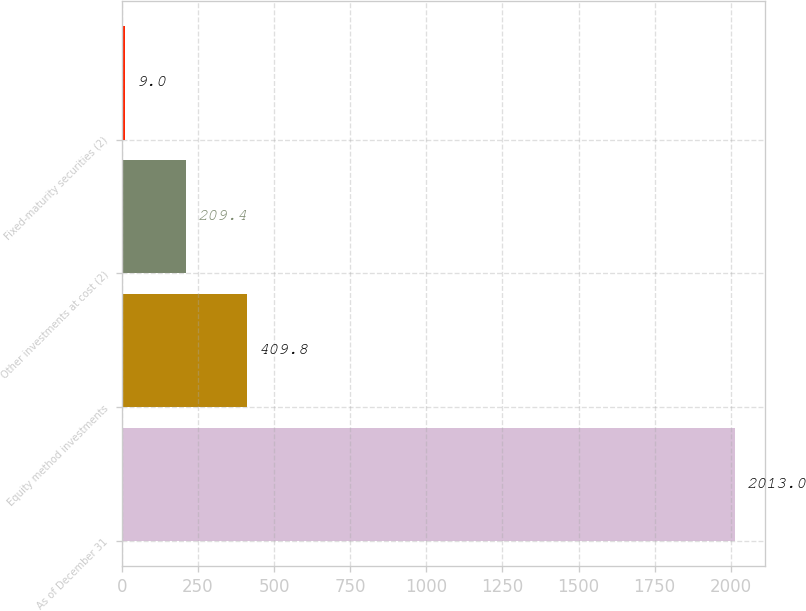Convert chart to OTSL. <chart><loc_0><loc_0><loc_500><loc_500><bar_chart><fcel>As of December 31<fcel>Equity method investments<fcel>Other investments at cost (2)<fcel>Fixed-maturity securities (2)<nl><fcel>2013<fcel>409.8<fcel>209.4<fcel>9<nl></chart> 